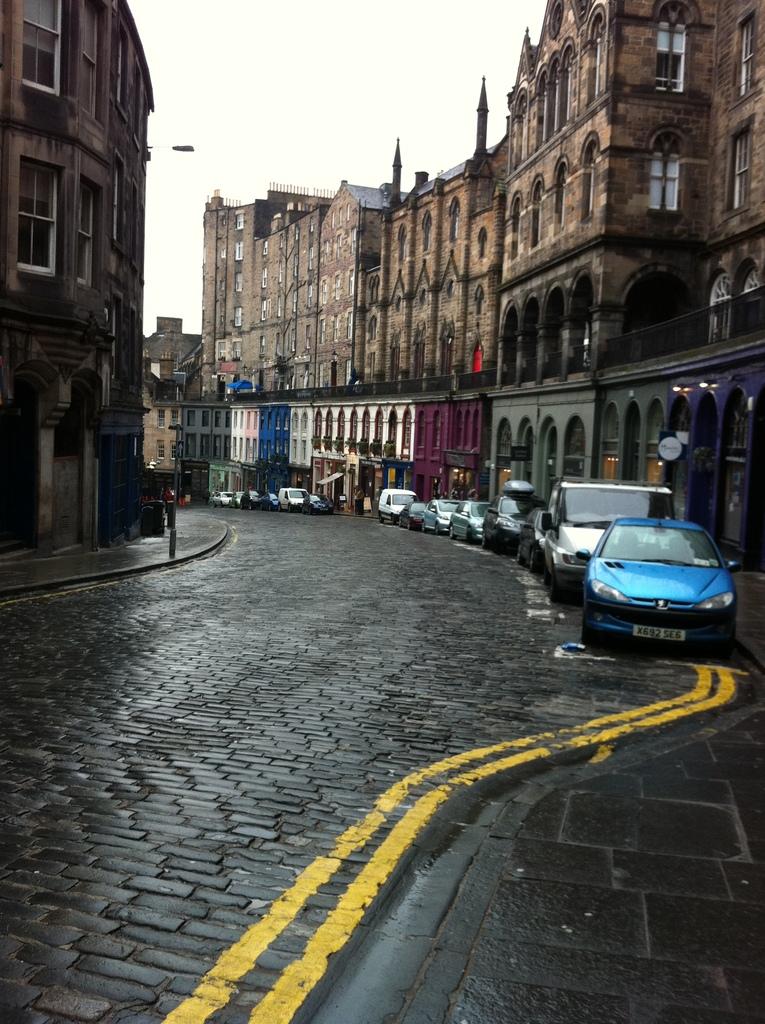What is the license plate number of the blue car?
Offer a very short reply. X692 se6. 